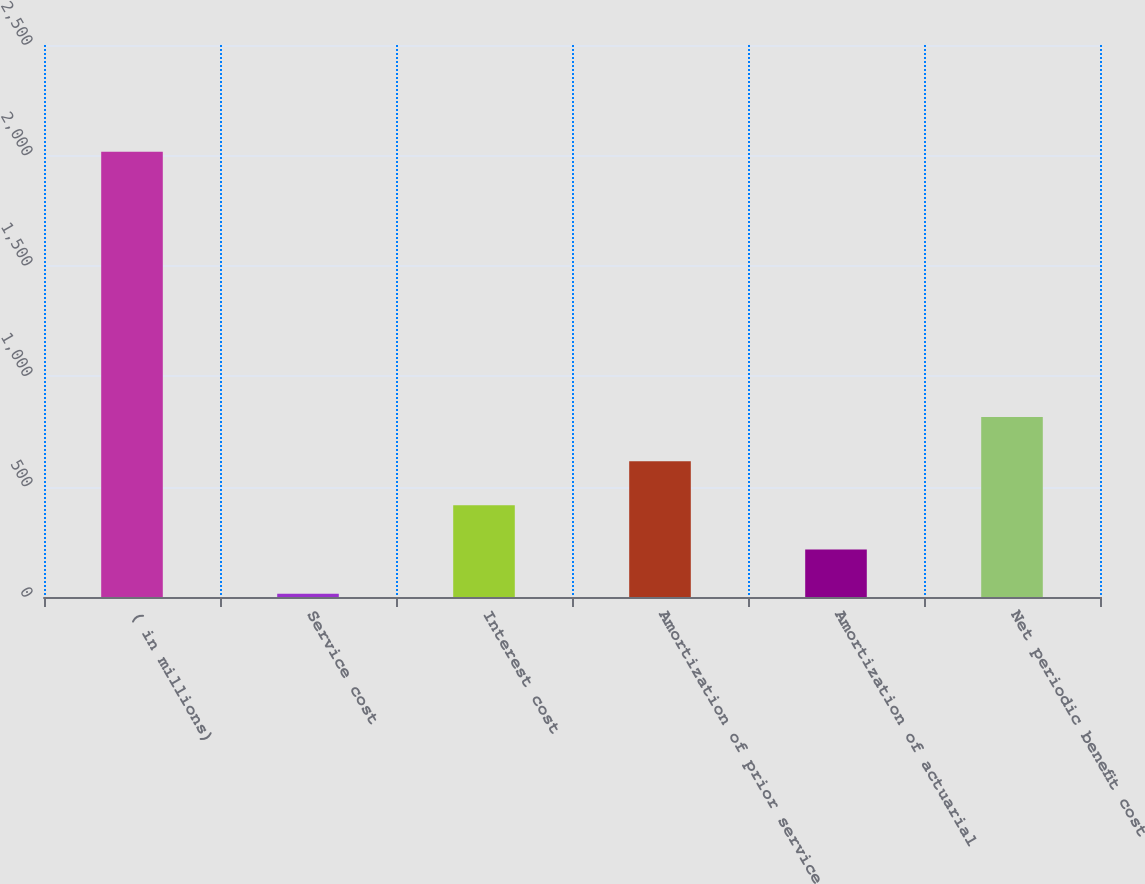Convert chart to OTSL. <chart><loc_0><loc_0><loc_500><loc_500><bar_chart><fcel>( in millions)<fcel>Service cost<fcel>Interest cost<fcel>Amortization of prior service<fcel>Amortization of actuarial<fcel>Net periodic benefit cost<nl><fcel>2016<fcel>15<fcel>415.2<fcel>615.3<fcel>215.1<fcel>815.4<nl></chart> 